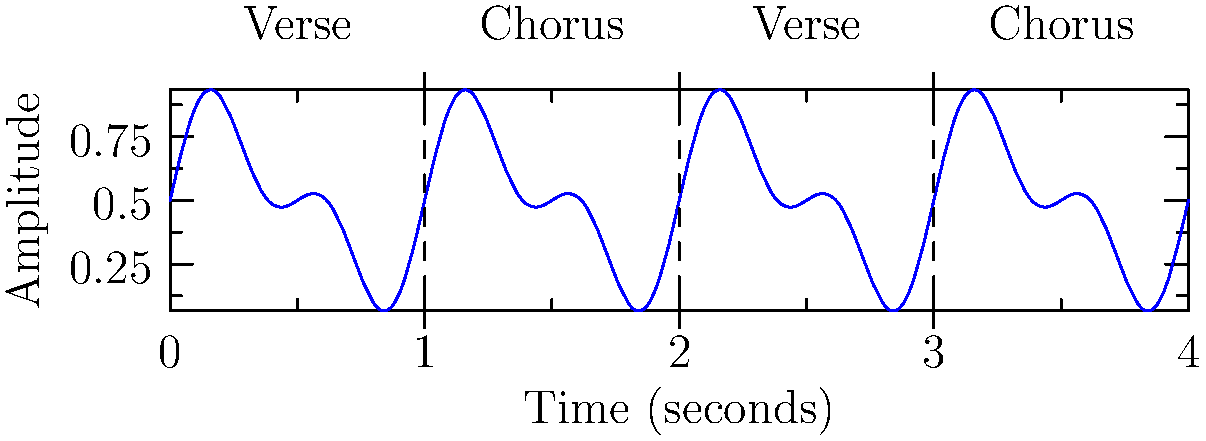Analyze the waveform diagram of a pop song's structure. What characteristic of the chorus distinguishes it from the verse in terms of amplitude? To analyze the structure of the pop song's chorus using the waveform diagram:

1. Observe the overall structure: The diagram shows a repeating pattern of verse-chorus-verse-chorus.

2. Examine the amplitude: 
   - The vertical axis represents amplitude, which correlates with the loudness or intensity of the sound.
   - Higher amplitude means louder or more intense sound.

3. Compare verse and chorus sections:
   - Verse sections (0-1 seconds and 2-3 seconds) have lower overall amplitude.
   - Chorus sections (1-2 seconds and 3-4 seconds) have higher overall amplitude.

4. Analyze the chorus characteristics:
   - The chorus shows larger waveforms, indicating higher amplitude.
   - This higher amplitude suggests that the chorus is louder and more energetic than the verse.

5. Interpret the musical significance:
   - In pop music, choruses are often designed to be more impactful and memorable.
   - The increased amplitude in the chorus helps achieve this by creating a more powerful sound.

Therefore, the key characteristic that distinguishes the chorus from the verse in this waveform is its higher amplitude, indicating greater loudness and energy.
Answer: Higher amplitude 